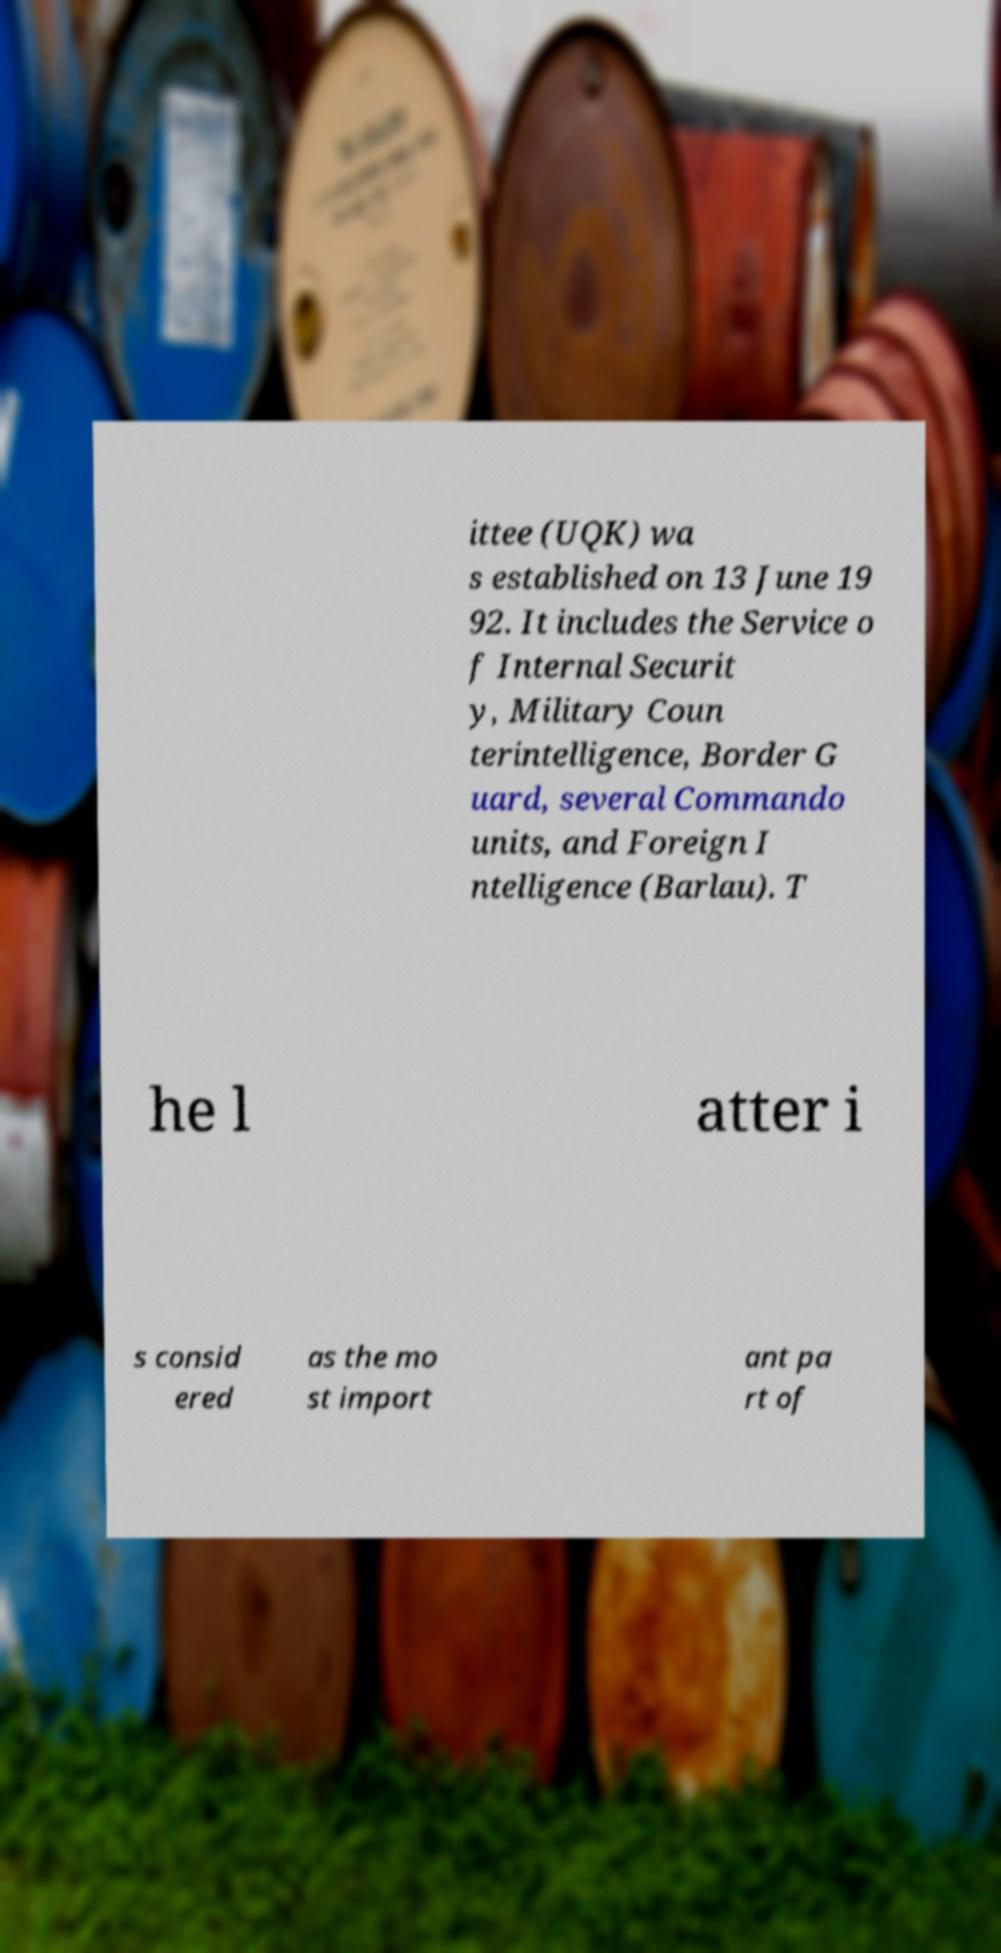Can you read and provide the text displayed in the image?This photo seems to have some interesting text. Can you extract and type it out for me? ittee (UQK) wa s established on 13 June 19 92. It includes the Service o f Internal Securit y, Military Coun terintelligence, Border G uard, several Commando units, and Foreign I ntelligence (Barlau). T he l atter i s consid ered as the mo st import ant pa rt of 